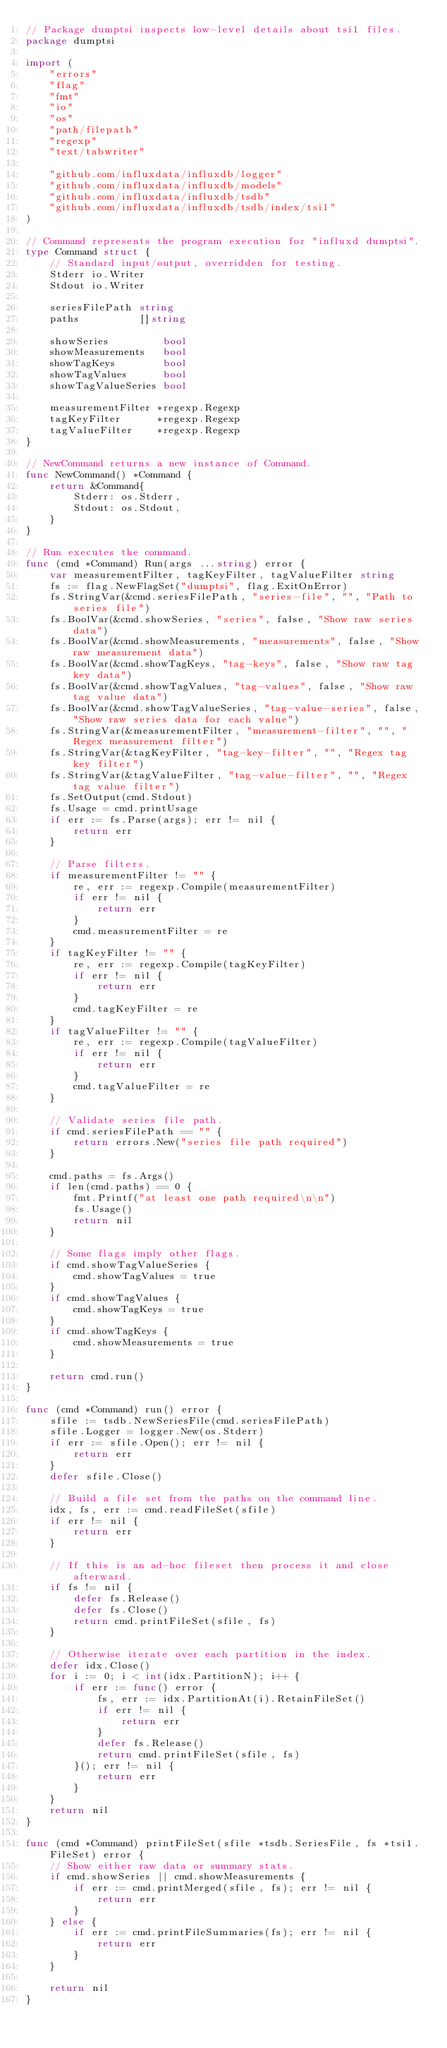<code> <loc_0><loc_0><loc_500><loc_500><_Go_>// Package dumptsi inspects low-level details about tsi1 files.
package dumptsi

import (
	"errors"
	"flag"
	"fmt"
	"io"
	"os"
	"path/filepath"
	"regexp"
	"text/tabwriter"

	"github.com/influxdata/influxdb/logger"
	"github.com/influxdata/influxdb/models"
	"github.com/influxdata/influxdb/tsdb"
	"github.com/influxdata/influxdb/tsdb/index/tsi1"
)

// Command represents the program execution for "influxd dumptsi".
type Command struct {
	// Standard input/output, overridden for testing.
	Stderr io.Writer
	Stdout io.Writer

	seriesFilePath string
	paths          []string

	showSeries         bool
	showMeasurements   bool
	showTagKeys        bool
	showTagValues      bool
	showTagValueSeries bool

	measurementFilter *regexp.Regexp
	tagKeyFilter      *regexp.Regexp
	tagValueFilter    *regexp.Regexp
}

// NewCommand returns a new instance of Command.
func NewCommand() *Command {
	return &Command{
		Stderr: os.Stderr,
		Stdout: os.Stdout,
	}
}

// Run executes the command.
func (cmd *Command) Run(args ...string) error {
	var measurementFilter, tagKeyFilter, tagValueFilter string
	fs := flag.NewFlagSet("dumptsi", flag.ExitOnError)
	fs.StringVar(&cmd.seriesFilePath, "series-file", "", "Path to series file")
	fs.BoolVar(&cmd.showSeries, "series", false, "Show raw series data")
	fs.BoolVar(&cmd.showMeasurements, "measurements", false, "Show raw measurement data")
	fs.BoolVar(&cmd.showTagKeys, "tag-keys", false, "Show raw tag key data")
	fs.BoolVar(&cmd.showTagValues, "tag-values", false, "Show raw tag value data")
	fs.BoolVar(&cmd.showTagValueSeries, "tag-value-series", false, "Show raw series data for each value")
	fs.StringVar(&measurementFilter, "measurement-filter", "", "Regex measurement filter")
	fs.StringVar(&tagKeyFilter, "tag-key-filter", "", "Regex tag key filter")
	fs.StringVar(&tagValueFilter, "tag-value-filter", "", "Regex tag value filter")
	fs.SetOutput(cmd.Stdout)
	fs.Usage = cmd.printUsage
	if err := fs.Parse(args); err != nil {
		return err
	}

	// Parse filters.
	if measurementFilter != "" {
		re, err := regexp.Compile(measurementFilter)
		if err != nil {
			return err
		}
		cmd.measurementFilter = re
	}
	if tagKeyFilter != "" {
		re, err := regexp.Compile(tagKeyFilter)
		if err != nil {
			return err
		}
		cmd.tagKeyFilter = re
	}
	if tagValueFilter != "" {
		re, err := regexp.Compile(tagValueFilter)
		if err != nil {
			return err
		}
		cmd.tagValueFilter = re
	}

	// Validate series file path.
	if cmd.seriesFilePath == "" {
		return errors.New("series file path required")
	}

	cmd.paths = fs.Args()
	if len(cmd.paths) == 0 {
		fmt.Printf("at least one path required\n\n")
		fs.Usage()
		return nil
	}

	// Some flags imply other flags.
	if cmd.showTagValueSeries {
		cmd.showTagValues = true
	}
	if cmd.showTagValues {
		cmd.showTagKeys = true
	}
	if cmd.showTagKeys {
		cmd.showMeasurements = true
	}

	return cmd.run()
}

func (cmd *Command) run() error {
	sfile := tsdb.NewSeriesFile(cmd.seriesFilePath)
	sfile.Logger = logger.New(os.Stderr)
	if err := sfile.Open(); err != nil {
		return err
	}
	defer sfile.Close()

	// Build a file set from the paths on the command line.
	idx, fs, err := cmd.readFileSet(sfile)
	if err != nil {
		return err
	}

	// If this is an ad-hoc fileset then process it and close afterward.
	if fs != nil {
		defer fs.Release()
		defer fs.Close()
		return cmd.printFileSet(sfile, fs)
	}

	// Otherwise iterate over each partition in the index.
	defer idx.Close()
	for i := 0; i < int(idx.PartitionN); i++ {
		if err := func() error {
			fs, err := idx.PartitionAt(i).RetainFileSet()
			if err != nil {
				return err
			}
			defer fs.Release()
			return cmd.printFileSet(sfile, fs)
		}(); err != nil {
			return err
		}
	}
	return nil
}

func (cmd *Command) printFileSet(sfile *tsdb.SeriesFile, fs *tsi1.FileSet) error {
	// Show either raw data or summary stats.
	if cmd.showSeries || cmd.showMeasurements {
		if err := cmd.printMerged(sfile, fs); err != nil {
			return err
		}
	} else {
		if err := cmd.printFileSummaries(fs); err != nil {
			return err
		}
	}

	return nil
}
</code> 